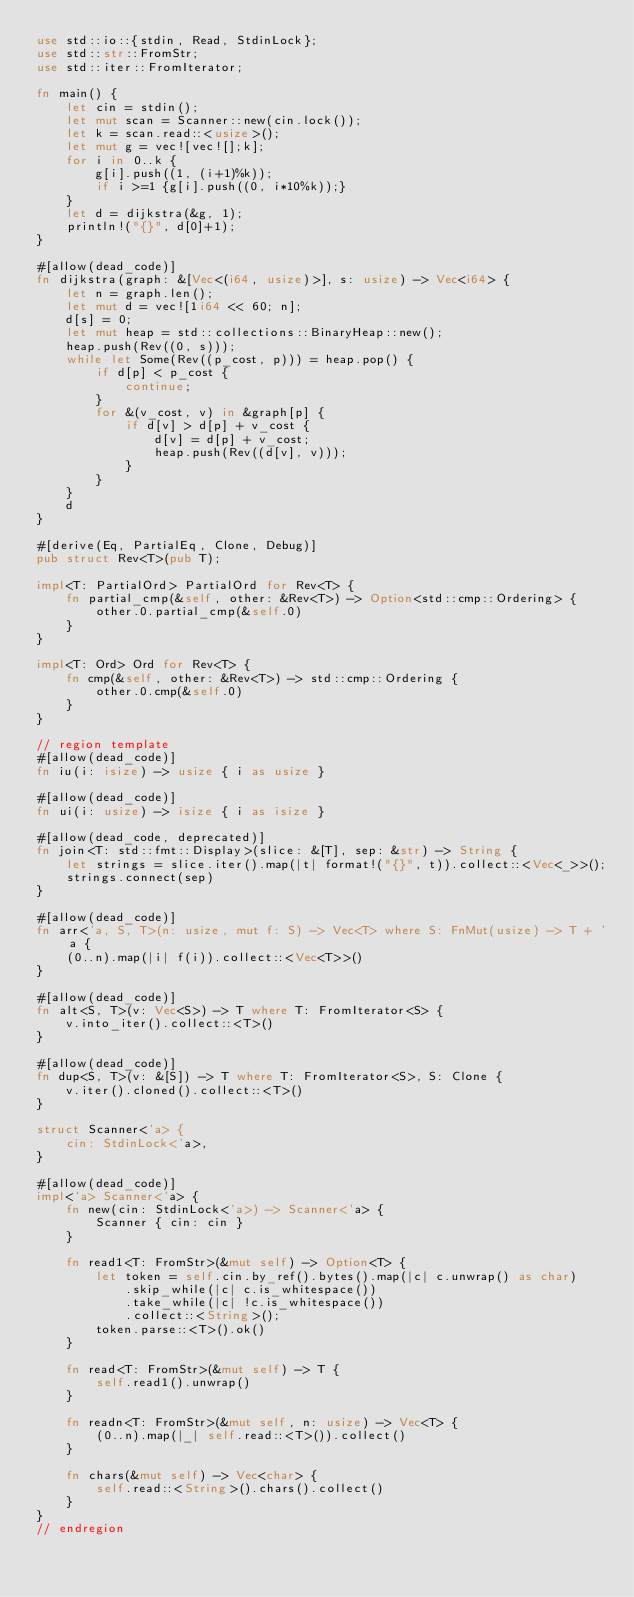<code> <loc_0><loc_0><loc_500><loc_500><_Rust_>use std::io::{stdin, Read, StdinLock};
use std::str::FromStr;
use std::iter::FromIterator;

fn main() {
    let cin = stdin();
    let mut scan = Scanner::new(cin.lock());
    let k = scan.read::<usize>();
    let mut g = vec![vec![];k];
    for i in 0..k {
        g[i].push((1, (i+1)%k));
        if i >=1 {g[i].push((0, i*10%k));}
    }
    let d = dijkstra(&g, 1);
    println!("{}", d[0]+1);
}

#[allow(dead_code)]
fn dijkstra(graph: &[Vec<(i64, usize)>], s: usize) -> Vec<i64> {
    let n = graph.len();
    let mut d = vec![1i64 << 60; n];
    d[s] = 0;
    let mut heap = std::collections::BinaryHeap::new();
    heap.push(Rev((0, s)));
    while let Some(Rev((p_cost, p))) = heap.pop() {
        if d[p] < p_cost {
            continue;
        }
        for &(v_cost, v) in &graph[p] {
            if d[v] > d[p] + v_cost {
                d[v] = d[p] + v_cost;
                heap.push(Rev((d[v], v)));
            }
        }
    }
    d
}

#[derive(Eq, PartialEq, Clone, Debug)]
pub struct Rev<T>(pub T);

impl<T: PartialOrd> PartialOrd for Rev<T> {
    fn partial_cmp(&self, other: &Rev<T>) -> Option<std::cmp::Ordering> {
        other.0.partial_cmp(&self.0)
    }
}

impl<T: Ord> Ord for Rev<T> {
    fn cmp(&self, other: &Rev<T>) -> std::cmp::Ordering {
        other.0.cmp(&self.0)
    }
}

// region template
#[allow(dead_code)]
fn iu(i: isize) -> usize { i as usize }

#[allow(dead_code)]
fn ui(i: usize) -> isize { i as isize }

#[allow(dead_code, deprecated)]
fn join<T: std::fmt::Display>(slice: &[T], sep: &str) -> String {
    let strings = slice.iter().map(|t| format!("{}", t)).collect::<Vec<_>>();
    strings.connect(sep)
}

#[allow(dead_code)]
fn arr<'a, S, T>(n: usize, mut f: S) -> Vec<T> where S: FnMut(usize) -> T + 'a {
    (0..n).map(|i| f(i)).collect::<Vec<T>>()
}

#[allow(dead_code)]
fn alt<S, T>(v: Vec<S>) -> T where T: FromIterator<S> {
    v.into_iter().collect::<T>()
}

#[allow(dead_code)]
fn dup<S, T>(v: &[S]) -> T where T: FromIterator<S>, S: Clone {
    v.iter().cloned().collect::<T>()
}

struct Scanner<'a> {
    cin: StdinLock<'a>,
}

#[allow(dead_code)]
impl<'a> Scanner<'a> {
    fn new(cin: StdinLock<'a>) -> Scanner<'a> {
        Scanner { cin: cin }
    }

    fn read1<T: FromStr>(&mut self) -> Option<T> {
        let token = self.cin.by_ref().bytes().map(|c| c.unwrap() as char)
            .skip_while(|c| c.is_whitespace())
            .take_while(|c| !c.is_whitespace())
            .collect::<String>();
        token.parse::<T>().ok()
    }

    fn read<T: FromStr>(&mut self) -> T {
        self.read1().unwrap()
    }

    fn readn<T: FromStr>(&mut self, n: usize) -> Vec<T> {
        (0..n).map(|_| self.read::<T>()).collect()
    }

    fn chars(&mut self) -> Vec<char> {
        self.read::<String>().chars().collect()
    }
}
// endregion</code> 